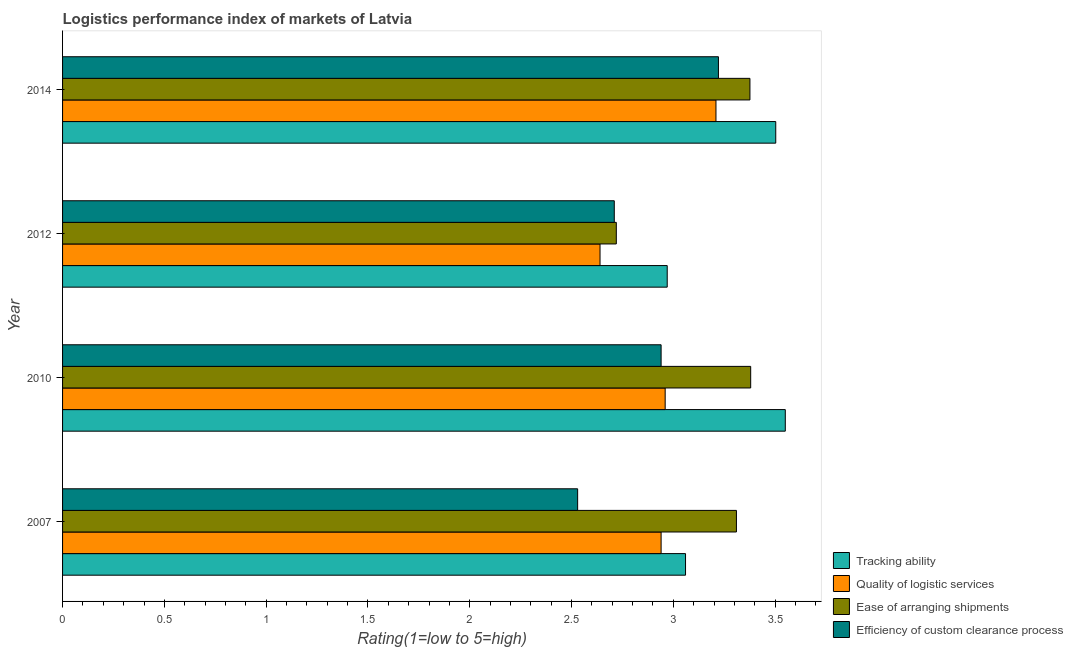How many different coloured bars are there?
Keep it short and to the point. 4. Are the number of bars per tick equal to the number of legend labels?
Offer a very short reply. Yes. What is the label of the 4th group of bars from the top?
Your answer should be compact. 2007. In how many cases, is the number of bars for a given year not equal to the number of legend labels?
Make the answer very short. 0. What is the lpi rating of efficiency of custom clearance process in 2010?
Your response must be concise. 2.94. Across all years, what is the maximum lpi rating of efficiency of custom clearance process?
Keep it short and to the point. 3.22. Across all years, what is the minimum lpi rating of tracking ability?
Your answer should be compact. 2.97. In which year was the lpi rating of quality of logistic services minimum?
Provide a succinct answer. 2012. What is the total lpi rating of tracking ability in the graph?
Provide a short and direct response. 13.08. What is the difference between the lpi rating of ease of arranging shipments in 2012 and that in 2014?
Make the answer very short. -0.66. What is the difference between the lpi rating of efficiency of custom clearance process in 2012 and the lpi rating of quality of logistic services in 2014?
Offer a terse response. -0.5. What is the average lpi rating of quality of logistic services per year?
Offer a terse response. 2.94. In the year 2012, what is the difference between the lpi rating of efficiency of custom clearance process and lpi rating of tracking ability?
Give a very brief answer. -0.26. What is the ratio of the lpi rating of tracking ability in 2010 to that in 2012?
Offer a very short reply. 1.2. Is the difference between the lpi rating of tracking ability in 2012 and 2014 greater than the difference between the lpi rating of quality of logistic services in 2012 and 2014?
Make the answer very short. Yes. What is the difference between the highest and the second highest lpi rating of ease of arranging shipments?
Offer a terse response. 0. What is the difference between the highest and the lowest lpi rating of efficiency of custom clearance process?
Provide a succinct answer. 0.69. Is the sum of the lpi rating of quality of logistic services in 2012 and 2014 greater than the maximum lpi rating of ease of arranging shipments across all years?
Give a very brief answer. Yes. Is it the case that in every year, the sum of the lpi rating of quality of logistic services and lpi rating of tracking ability is greater than the sum of lpi rating of ease of arranging shipments and lpi rating of efficiency of custom clearance process?
Your response must be concise. No. What does the 1st bar from the top in 2014 represents?
Offer a very short reply. Efficiency of custom clearance process. What does the 1st bar from the bottom in 2010 represents?
Provide a short and direct response. Tracking ability. How many bars are there?
Your answer should be compact. 16. Are the values on the major ticks of X-axis written in scientific E-notation?
Offer a terse response. No. Does the graph contain any zero values?
Offer a terse response. No. Does the graph contain grids?
Provide a succinct answer. No. What is the title of the graph?
Your answer should be compact. Logistics performance index of markets of Latvia. What is the label or title of the X-axis?
Your answer should be very brief. Rating(1=low to 5=high). What is the label or title of the Y-axis?
Your answer should be compact. Year. What is the Rating(1=low to 5=high) in Tracking ability in 2007?
Keep it short and to the point. 3.06. What is the Rating(1=low to 5=high) of Quality of logistic services in 2007?
Provide a short and direct response. 2.94. What is the Rating(1=low to 5=high) of Ease of arranging shipments in 2007?
Your answer should be very brief. 3.31. What is the Rating(1=low to 5=high) in Efficiency of custom clearance process in 2007?
Ensure brevity in your answer.  2.53. What is the Rating(1=low to 5=high) of Tracking ability in 2010?
Provide a short and direct response. 3.55. What is the Rating(1=low to 5=high) of Quality of logistic services in 2010?
Ensure brevity in your answer.  2.96. What is the Rating(1=low to 5=high) in Ease of arranging shipments in 2010?
Your response must be concise. 3.38. What is the Rating(1=low to 5=high) of Efficiency of custom clearance process in 2010?
Keep it short and to the point. 2.94. What is the Rating(1=low to 5=high) in Tracking ability in 2012?
Keep it short and to the point. 2.97. What is the Rating(1=low to 5=high) of Quality of logistic services in 2012?
Give a very brief answer. 2.64. What is the Rating(1=low to 5=high) of Ease of arranging shipments in 2012?
Your answer should be very brief. 2.72. What is the Rating(1=low to 5=high) of Efficiency of custom clearance process in 2012?
Make the answer very short. 2.71. What is the Rating(1=low to 5=high) in Tracking ability in 2014?
Ensure brevity in your answer.  3.5. What is the Rating(1=low to 5=high) of Quality of logistic services in 2014?
Your answer should be compact. 3.21. What is the Rating(1=low to 5=high) in Ease of arranging shipments in 2014?
Your answer should be very brief. 3.38. What is the Rating(1=low to 5=high) in Efficiency of custom clearance process in 2014?
Your response must be concise. 3.22. Across all years, what is the maximum Rating(1=low to 5=high) of Tracking ability?
Provide a short and direct response. 3.55. Across all years, what is the maximum Rating(1=low to 5=high) of Quality of logistic services?
Keep it short and to the point. 3.21. Across all years, what is the maximum Rating(1=low to 5=high) in Ease of arranging shipments?
Your response must be concise. 3.38. Across all years, what is the maximum Rating(1=low to 5=high) of Efficiency of custom clearance process?
Provide a short and direct response. 3.22. Across all years, what is the minimum Rating(1=low to 5=high) of Tracking ability?
Your answer should be very brief. 2.97. Across all years, what is the minimum Rating(1=low to 5=high) in Quality of logistic services?
Your answer should be very brief. 2.64. Across all years, what is the minimum Rating(1=low to 5=high) in Ease of arranging shipments?
Keep it short and to the point. 2.72. Across all years, what is the minimum Rating(1=low to 5=high) in Efficiency of custom clearance process?
Make the answer very short. 2.53. What is the total Rating(1=low to 5=high) of Tracking ability in the graph?
Provide a short and direct response. 13.08. What is the total Rating(1=low to 5=high) in Quality of logistic services in the graph?
Your response must be concise. 11.75. What is the total Rating(1=low to 5=high) of Ease of arranging shipments in the graph?
Make the answer very short. 12.79. What is the total Rating(1=low to 5=high) in Efficiency of custom clearance process in the graph?
Offer a terse response. 11.4. What is the difference between the Rating(1=low to 5=high) in Tracking ability in 2007 and that in 2010?
Offer a very short reply. -0.49. What is the difference between the Rating(1=low to 5=high) of Quality of logistic services in 2007 and that in 2010?
Offer a very short reply. -0.02. What is the difference between the Rating(1=low to 5=high) in Ease of arranging shipments in 2007 and that in 2010?
Provide a short and direct response. -0.07. What is the difference between the Rating(1=low to 5=high) in Efficiency of custom clearance process in 2007 and that in 2010?
Your answer should be very brief. -0.41. What is the difference between the Rating(1=low to 5=high) of Tracking ability in 2007 and that in 2012?
Ensure brevity in your answer.  0.09. What is the difference between the Rating(1=low to 5=high) of Quality of logistic services in 2007 and that in 2012?
Give a very brief answer. 0.3. What is the difference between the Rating(1=low to 5=high) in Ease of arranging shipments in 2007 and that in 2012?
Offer a very short reply. 0.59. What is the difference between the Rating(1=low to 5=high) in Efficiency of custom clearance process in 2007 and that in 2012?
Keep it short and to the point. -0.18. What is the difference between the Rating(1=low to 5=high) of Tracking ability in 2007 and that in 2014?
Ensure brevity in your answer.  -0.44. What is the difference between the Rating(1=low to 5=high) in Quality of logistic services in 2007 and that in 2014?
Provide a succinct answer. -0.27. What is the difference between the Rating(1=low to 5=high) of Ease of arranging shipments in 2007 and that in 2014?
Ensure brevity in your answer.  -0.07. What is the difference between the Rating(1=low to 5=high) in Efficiency of custom clearance process in 2007 and that in 2014?
Keep it short and to the point. -0.69. What is the difference between the Rating(1=low to 5=high) in Tracking ability in 2010 and that in 2012?
Provide a short and direct response. 0.58. What is the difference between the Rating(1=low to 5=high) of Quality of logistic services in 2010 and that in 2012?
Offer a terse response. 0.32. What is the difference between the Rating(1=low to 5=high) in Ease of arranging shipments in 2010 and that in 2012?
Offer a very short reply. 0.66. What is the difference between the Rating(1=low to 5=high) of Efficiency of custom clearance process in 2010 and that in 2012?
Ensure brevity in your answer.  0.23. What is the difference between the Rating(1=low to 5=high) in Tracking ability in 2010 and that in 2014?
Your response must be concise. 0.05. What is the difference between the Rating(1=low to 5=high) in Quality of logistic services in 2010 and that in 2014?
Provide a short and direct response. -0.25. What is the difference between the Rating(1=low to 5=high) in Ease of arranging shipments in 2010 and that in 2014?
Your response must be concise. 0. What is the difference between the Rating(1=low to 5=high) of Efficiency of custom clearance process in 2010 and that in 2014?
Make the answer very short. -0.28. What is the difference between the Rating(1=low to 5=high) of Tracking ability in 2012 and that in 2014?
Keep it short and to the point. -0.53. What is the difference between the Rating(1=low to 5=high) in Quality of logistic services in 2012 and that in 2014?
Ensure brevity in your answer.  -0.57. What is the difference between the Rating(1=low to 5=high) in Ease of arranging shipments in 2012 and that in 2014?
Provide a succinct answer. -0.66. What is the difference between the Rating(1=low to 5=high) in Efficiency of custom clearance process in 2012 and that in 2014?
Your response must be concise. -0.51. What is the difference between the Rating(1=low to 5=high) of Tracking ability in 2007 and the Rating(1=low to 5=high) of Ease of arranging shipments in 2010?
Provide a short and direct response. -0.32. What is the difference between the Rating(1=low to 5=high) of Tracking ability in 2007 and the Rating(1=low to 5=high) of Efficiency of custom clearance process in 2010?
Ensure brevity in your answer.  0.12. What is the difference between the Rating(1=low to 5=high) of Quality of logistic services in 2007 and the Rating(1=low to 5=high) of Ease of arranging shipments in 2010?
Ensure brevity in your answer.  -0.44. What is the difference between the Rating(1=low to 5=high) in Quality of logistic services in 2007 and the Rating(1=low to 5=high) in Efficiency of custom clearance process in 2010?
Your answer should be very brief. 0. What is the difference between the Rating(1=low to 5=high) in Ease of arranging shipments in 2007 and the Rating(1=low to 5=high) in Efficiency of custom clearance process in 2010?
Your answer should be compact. 0.37. What is the difference between the Rating(1=low to 5=high) in Tracking ability in 2007 and the Rating(1=low to 5=high) in Quality of logistic services in 2012?
Offer a very short reply. 0.42. What is the difference between the Rating(1=low to 5=high) in Tracking ability in 2007 and the Rating(1=low to 5=high) in Ease of arranging shipments in 2012?
Give a very brief answer. 0.34. What is the difference between the Rating(1=low to 5=high) of Tracking ability in 2007 and the Rating(1=low to 5=high) of Efficiency of custom clearance process in 2012?
Give a very brief answer. 0.35. What is the difference between the Rating(1=low to 5=high) of Quality of logistic services in 2007 and the Rating(1=low to 5=high) of Ease of arranging shipments in 2012?
Keep it short and to the point. 0.22. What is the difference between the Rating(1=low to 5=high) of Quality of logistic services in 2007 and the Rating(1=low to 5=high) of Efficiency of custom clearance process in 2012?
Your answer should be compact. 0.23. What is the difference between the Rating(1=low to 5=high) of Tracking ability in 2007 and the Rating(1=low to 5=high) of Quality of logistic services in 2014?
Your answer should be very brief. -0.15. What is the difference between the Rating(1=low to 5=high) of Tracking ability in 2007 and the Rating(1=low to 5=high) of Ease of arranging shipments in 2014?
Your response must be concise. -0.32. What is the difference between the Rating(1=low to 5=high) of Tracking ability in 2007 and the Rating(1=low to 5=high) of Efficiency of custom clearance process in 2014?
Give a very brief answer. -0.16. What is the difference between the Rating(1=low to 5=high) of Quality of logistic services in 2007 and the Rating(1=low to 5=high) of Ease of arranging shipments in 2014?
Make the answer very short. -0.44. What is the difference between the Rating(1=low to 5=high) of Quality of logistic services in 2007 and the Rating(1=low to 5=high) of Efficiency of custom clearance process in 2014?
Keep it short and to the point. -0.28. What is the difference between the Rating(1=low to 5=high) of Ease of arranging shipments in 2007 and the Rating(1=low to 5=high) of Efficiency of custom clearance process in 2014?
Your response must be concise. 0.09. What is the difference between the Rating(1=low to 5=high) of Tracking ability in 2010 and the Rating(1=low to 5=high) of Quality of logistic services in 2012?
Keep it short and to the point. 0.91. What is the difference between the Rating(1=low to 5=high) in Tracking ability in 2010 and the Rating(1=low to 5=high) in Ease of arranging shipments in 2012?
Your answer should be compact. 0.83. What is the difference between the Rating(1=low to 5=high) of Tracking ability in 2010 and the Rating(1=low to 5=high) of Efficiency of custom clearance process in 2012?
Make the answer very short. 0.84. What is the difference between the Rating(1=low to 5=high) of Quality of logistic services in 2010 and the Rating(1=low to 5=high) of Ease of arranging shipments in 2012?
Your answer should be very brief. 0.24. What is the difference between the Rating(1=low to 5=high) in Ease of arranging shipments in 2010 and the Rating(1=low to 5=high) in Efficiency of custom clearance process in 2012?
Give a very brief answer. 0.67. What is the difference between the Rating(1=low to 5=high) of Tracking ability in 2010 and the Rating(1=low to 5=high) of Quality of logistic services in 2014?
Your answer should be compact. 0.34. What is the difference between the Rating(1=low to 5=high) in Tracking ability in 2010 and the Rating(1=low to 5=high) in Ease of arranging shipments in 2014?
Your answer should be compact. 0.17. What is the difference between the Rating(1=low to 5=high) in Tracking ability in 2010 and the Rating(1=low to 5=high) in Efficiency of custom clearance process in 2014?
Keep it short and to the point. 0.33. What is the difference between the Rating(1=low to 5=high) of Quality of logistic services in 2010 and the Rating(1=low to 5=high) of Ease of arranging shipments in 2014?
Provide a short and direct response. -0.42. What is the difference between the Rating(1=low to 5=high) of Quality of logistic services in 2010 and the Rating(1=low to 5=high) of Efficiency of custom clearance process in 2014?
Provide a short and direct response. -0.26. What is the difference between the Rating(1=low to 5=high) of Ease of arranging shipments in 2010 and the Rating(1=low to 5=high) of Efficiency of custom clearance process in 2014?
Your answer should be very brief. 0.16. What is the difference between the Rating(1=low to 5=high) of Tracking ability in 2012 and the Rating(1=low to 5=high) of Quality of logistic services in 2014?
Offer a very short reply. -0.24. What is the difference between the Rating(1=low to 5=high) of Tracking ability in 2012 and the Rating(1=low to 5=high) of Ease of arranging shipments in 2014?
Offer a very short reply. -0.41. What is the difference between the Rating(1=low to 5=high) of Tracking ability in 2012 and the Rating(1=low to 5=high) of Efficiency of custom clearance process in 2014?
Your answer should be compact. -0.25. What is the difference between the Rating(1=low to 5=high) in Quality of logistic services in 2012 and the Rating(1=low to 5=high) in Ease of arranging shipments in 2014?
Provide a short and direct response. -0.74. What is the difference between the Rating(1=low to 5=high) in Quality of logistic services in 2012 and the Rating(1=low to 5=high) in Efficiency of custom clearance process in 2014?
Make the answer very short. -0.58. What is the difference between the Rating(1=low to 5=high) in Ease of arranging shipments in 2012 and the Rating(1=low to 5=high) in Efficiency of custom clearance process in 2014?
Give a very brief answer. -0.5. What is the average Rating(1=low to 5=high) of Tracking ability per year?
Provide a short and direct response. 3.27. What is the average Rating(1=low to 5=high) in Quality of logistic services per year?
Give a very brief answer. 2.94. What is the average Rating(1=low to 5=high) in Ease of arranging shipments per year?
Offer a very short reply. 3.2. What is the average Rating(1=low to 5=high) in Efficiency of custom clearance process per year?
Offer a terse response. 2.85. In the year 2007, what is the difference between the Rating(1=low to 5=high) in Tracking ability and Rating(1=low to 5=high) in Quality of logistic services?
Give a very brief answer. 0.12. In the year 2007, what is the difference between the Rating(1=low to 5=high) of Tracking ability and Rating(1=low to 5=high) of Efficiency of custom clearance process?
Ensure brevity in your answer.  0.53. In the year 2007, what is the difference between the Rating(1=low to 5=high) of Quality of logistic services and Rating(1=low to 5=high) of Ease of arranging shipments?
Keep it short and to the point. -0.37. In the year 2007, what is the difference between the Rating(1=low to 5=high) in Quality of logistic services and Rating(1=low to 5=high) in Efficiency of custom clearance process?
Offer a very short reply. 0.41. In the year 2007, what is the difference between the Rating(1=low to 5=high) in Ease of arranging shipments and Rating(1=low to 5=high) in Efficiency of custom clearance process?
Your response must be concise. 0.78. In the year 2010, what is the difference between the Rating(1=low to 5=high) in Tracking ability and Rating(1=low to 5=high) in Quality of logistic services?
Offer a very short reply. 0.59. In the year 2010, what is the difference between the Rating(1=low to 5=high) of Tracking ability and Rating(1=low to 5=high) of Ease of arranging shipments?
Keep it short and to the point. 0.17. In the year 2010, what is the difference between the Rating(1=low to 5=high) of Tracking ability and Rating(1=low to 5=high) of Efficiency of custom clearance process?
Your answer should be compact. 0.61. In the year 2010, what is the difference between the Rating(1=low to 5=high) in Quality of logistic services and Rating(1=low to 5=high) in Ease of arranging shipments?
Your answer should be very brief. -0.42. In the year 2010, what is the difference between the Rating(1=low to 5=high) of Quality of logistic services and Rating(1=low to 5=high) of Efficiency of custom clearance process?
Give a very brief answer. 0.02. In the year 2010, what is the difference between the Rating(1=low to 5=high) of Ease of arranging shipments and Rating(1=low to 5=high) of Efficiency of custom clearance process?
Keep it short and to the point. 0.44. In the year 2012, what is the difference between the Rating(1=low to 5=high) of Tracking ability and Rating(1=low to 5=high) of Quality of logistic services?
Keep it short and to the point. 0.33. In the year 2012, what is the difference between the Rating(1=low to 5=high) of Tracking ability and Rating(1=low to 5=high) of Ease of arranging shipments?
Your answer should be very brief. 0.25. In the year 2012, what is the difference between the Rating(1=low to 5=high) in Tracking ability and Rating(1=low to 5=high) in Efficiency of custom clearance process?
Keep it short and to the point. 0.26. In the year 2012, what is the difference between the Rating(1=low to 5=high) in Quality of logistic services and Rating(1=low to 5=high) in Ease of arranging shipments?
Your answer should be compact. -0.08. In the year 2012, what is the difference between the Rating(1=low to 5=high) in Quality of logistic services and Rating(1=low to 5=high) in Efficiency of custom clearance process?
Provide a succinct answer. -0.07. In the year 2012, what is the difference between the Rating(1=low to 5=high) in Ease of arranging shipments and Rating(1=low to 5=high) in Efficiency of custom clearance process?
Offer a very short reply. 0.01. In the year 2014, what is the difference between the Rating(1=low to 5=high) of Tracking ability and Rating(1=low to 5=high) of Quality of logistic services?
Your answer should be very brief. 0.29. In the year 2014, what is the difference between the Rating(1=low to 5=high) in Tracking ability and Rating(1=low to 5=high) in Ease of arranging shipments?
Offer a very short reply. 0.13. In the year 2014, what is the difference between the Rating(1=low to 5=high) in Tracking ability and Rating(1=low to 5=high) in Efficiency of custom clearance process?
Make the answer very short. 0.28. In the year 2014, what is the difference between the Rating(1=low to 5=high) of Quality of logistic services and Rating(1=low to 5=high) of Ease of arranging shipments?
Offer a terse response. -0.17. In the year 2014, what is the difference between the Rating(1=low to 5=high) of Quality of logistic services and Rating(1=low to 5=high) of Efficiency of custom clearance process?
Your answer should be very brief. -0.01. In the year 2014, what is the difference between the Rating(1=low to 5=high) of Ease of arranging shipments and Rating(1=low to 5=high) of Efficiency of custom clearance process?
Provide a short and direct response. 0.15. What is the ratio of the Rating(1=low to 5=high) of Tracking ability in 2007 to that in 2010?
Keep it short and to the point. 0.86. What is the ratio of the Rating(1=low to 5=high) in Quality of logistic services in 2007 to that in 2010?
Ensure brevity in your answer.  0.99. What is the ratio of the Rating(1=low to 5=high) in Ease of arranging shipments in 2007 to that in 2010?
Keep it short and to the point. 0.98. What is the ratio of the Rating(1=low to 5=high) in Efficiency of custom clearance process in 2007 to that in 2010?
Provide a short and direct response. 0.86. What is the ratio of the Rating(1=low to 5=high) of Tracking ability in 2007 to that in 2012?
Provide a succinct answer. 1.03. What is the ratio of the Rating(1=low to 5=high) of Quality of logistic services in 2007 to that in 2012?
Provide a short and direct response. 1.11. What is the ratio of the Rating(1=low to 5=high) of Ease of arranging shipments in 2007 to that in 2012?
Make the answer very short. 1.22. What is the ratio of the Rating(1=low to 5=high) in Efficiency of custom clearance process in 2007 to that in 2012?
Provide a short and direct response. 0.93. What is the ratio of the Rating(1=low to 5=high) in Tracking ability in 2007 to that in 2014?
Give a very brief answer. 0.87. What is the ratio of the Rating(1=low to 5=high) in Quality of logistic services in 2007 to that in 2014?
Give a very brief answer. 0.92. What is the ratio of the Rating(1=low to 5=high) in Ease of arranging shipments in 2007 to that in 2014?
Offer a very short reply. 0.98. What is the ratio of the Rating(1=low to 5=high) in Efficiency of custom clearance process in 2007 to that in 2014?
Give a very brief answer. 0.79. What is the ratio of the Rating(1=low to 5=high) of Tracking ability in 2010 to that in 2012?
Your answer should be very brief. 1.2. What is the ratio of the Rating(1=low to 5=high) in Quality of logistic services in 2010 to that in 2012?
Your answer should be compact. 1.12. What is the ratio of the Rating(1=low to 5=high) in Ease of arranging shipments in 2010 to that in 2012?
Your answer should be very brief. 1.24. What is the ratio of the Rating(1=low to 5=high) of Efficiency of custom clearance process in 2010 to that in 2012?
Your answer should be very brief. 1.08. What is the ratio of the Rating(1=low to 5=high) in Tracking ability in 2010 to that in 2014?
Make the answer very short. 1.01. What is the ratio of the Rating(1=low to 5=high) in Quality of logistic services in 2010 to that in 2014?
Give a very brief answer. 0.92. What is the ratio of the Rating(1=low to 5=high) in Efficiency of custom clearance process in 2010 to that in 2014?
Provide a succinct answer. 0.91. What is the ratio of the Rating(1=low to 5=high) in Tracking ability in 2012 to that in 2014?
Offer a terse response. 0.85. What is the ratio of the Rating(1=low to 5=high) in Quality of logistic services in 2012 to that in 2014?
Make the answer very short. 0.82. What is the ratio of the Rating(1=low to 5=high) in Ease of arranging shipments in 2012 to that in 2014?
Keep it short and to the point. 0.81. What is the ratio of the Rating(1=low to 5=high) in Efficiency of custom clearance process in 2012 to that in 2014?
Offer a terse response. 0.84. What is the difference between the highest and the second highest Rating(1=low to 5=high) of Tracking ability?
Provide a succinct answer. 0.05. What is the difference between the highest and the second highest Rating(1=low to 5=high) in Quality of logistic services?
Provide a short and direct response. 0.25. What is the difference between the highest and the second highest Rating(1=low to 5=high) of Ease of arranging shipments?
Provide a succinct answer. 0. What is the difference between the highest and the second highest Rating(1=low to 5=high) of Efficiency of custom clearance process?
Ensure brevity in your answer.  0.28. What is the difference between the highest and the lowest Rating(1=low to 5=high) of Tracking ability?
Provide a succinct answer. 0.58. What is the difference between the highest and the lowest Rating(1=low to 5=high) of Quality of logistic services?
Give a very brief answer. 0.57. What is the difference between the highest and the lowest Rating(1=low to 5=high) of Ease of arranging shipments?
Keep it short and to the point. 0.66. What is the difference between the highest and the lowest Rating(1=low to 5=high) in Efficiency of custom clearance process?
Offer a terse response. 0.69. 